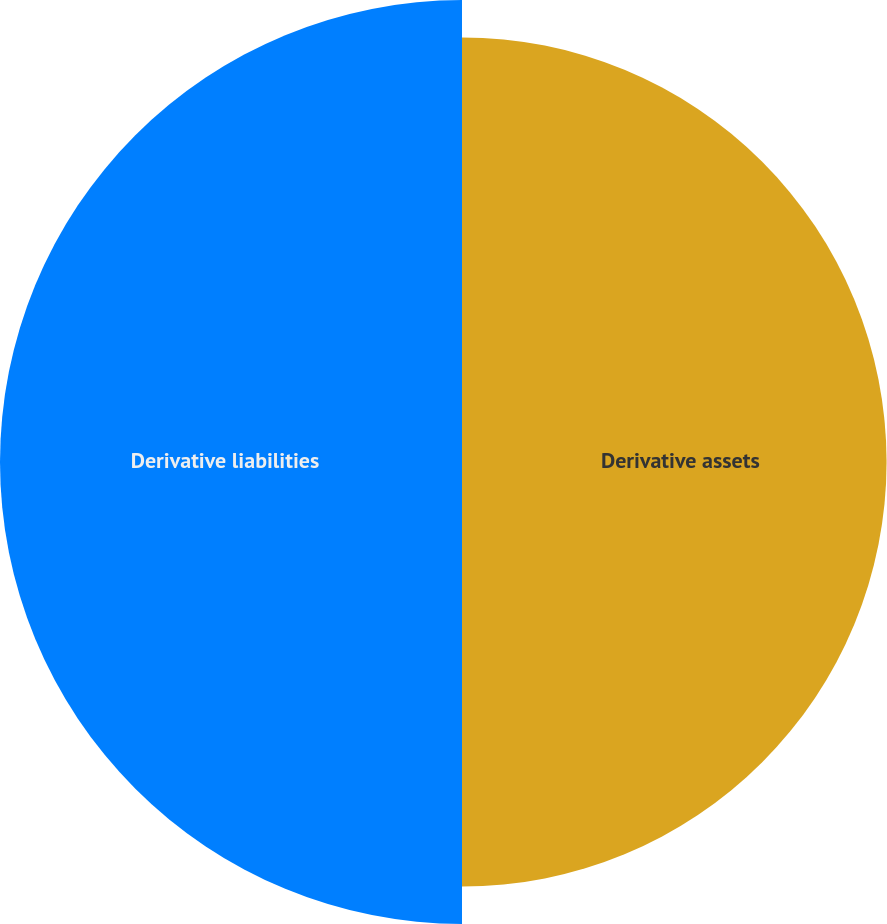Convert chart. <chart><loc_0><loc_0><loc_500><loc_500><pie_chart><fcel>Derivative assets<fcel>Derivative liabilities<nl><fcel>47.89%<fcel>52.11%<nl></chart> 